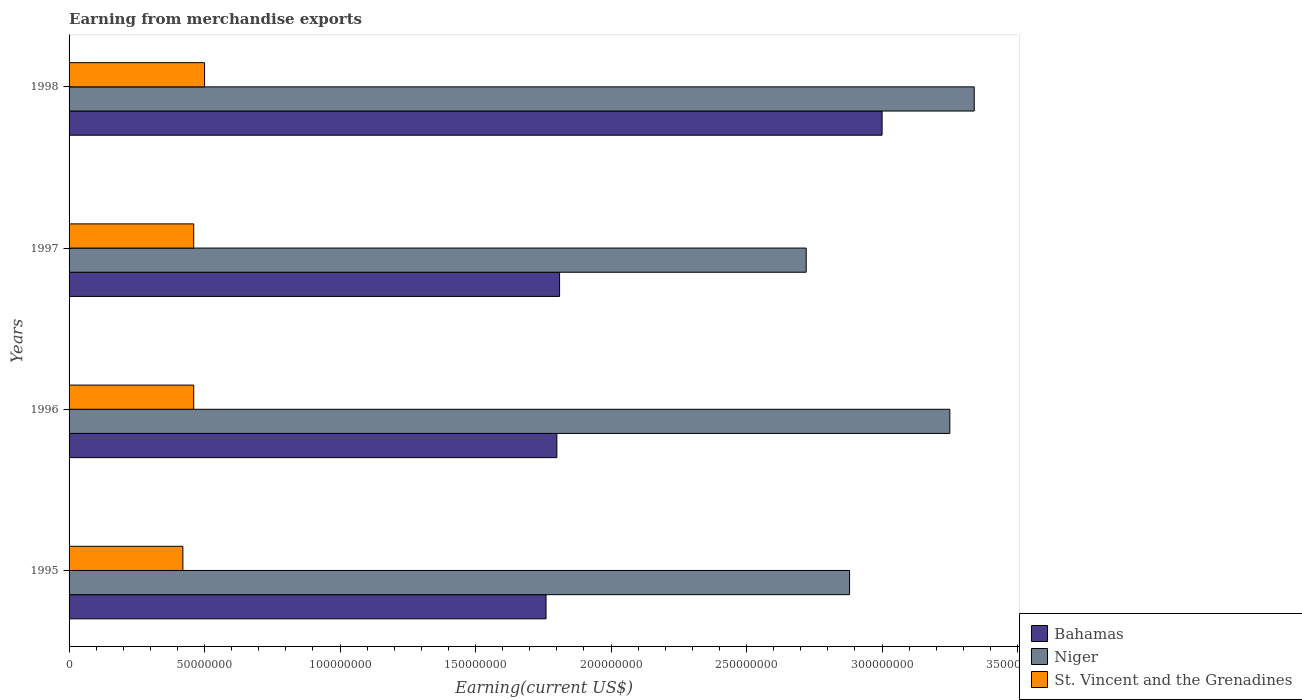How many different coloured bars are there?
Keep it short and to the point. 3. How many groups of bars are there?
Provide a succinct answer. 4. Are the number of bars per tick equal to the number of legend labels?
Your answer should be compact. Yes. Are the number of bars on each tick of the Y-axis equal?
Your answer should be compact. Yes. How many bars are there on the 2nd tick from the top?
Provide a succinct answer. 3. What is the label of the 1st group of bars from the top?
Offer a terse response. 1998. What is the amount earned from merchandise exports in Niger in 1996?
Your answer should be compact. 3.25e+08. Across all years, what is the minimum amount earned from merchandise exports in St. Vincent and the Grenadines?
Make the answer very short. 4.20e+07. In which year was the amount earned from merchandise exports in Niger maximum?
Provide a short and direct response. 1998. What is the total amount earned from merchandise exports in Niger in the graph?
Offer a terse response. 1.22e+09. What is the difference between the amount earned from merchandise exports in St. Vincent and the Grenadines in 1997 and the amount earned from merchandise exports in Niger in 1998?
Provide a short and direct response. -2.88e+08. What is the average amount earned from merchandise exports in Niger per year?
Make the answer very short. 3.05e+08. In the year 1995, what is the difference between the amount earned from merchandise exports in Niger and amount earned from merchandise exports in St. Vincent and the Grenadines?
Offer a terse response. 2.46e+08. In how many years, is the amount earned from merchandise exports in Bahamas greater than 340000000 US$?
Your answer should be very brief. 0. What is the ratio of the amount earned from merchandise exports in Bahamas in 1995 to that in 1996?
Your response must be concise. 0.98. Is the amount earned from merchandise exports in Bahamas in 1995 less than that in 1998?
Your answer should be very brief. Yes. What is the difference between the highest and the second highest amount earned from merchandise exports in Niger?
Give a very brief answer. 9.00e+06. What is the difference between the highest and the lowest amount earned from merchandise exports in Bahamas?
Keep it short and to the point. 1.24e+08. What does the 2nd bar from the top in 1998 represents?
Provide a succinct answer. Niger. What does the 2nd bar from the bottom in 1997 represents?
Offer a terse response. Niger. How many years are there in the graph?
Your answer should be compact. 4. Does the graph contain any zero values?
Your answer should be compact. No. Where does the legend appear in the graph?
Ensure brevity in your answer.  Bottom right. What is the title of the graph?
Offer a very short reply. Earning from merchandise exports. Does "Brazil" appear as one of the legend labels in the graph?
Your answer should be very brief. No. What is the label or title of the X-axis?
Your response must be concise. Earning(current US$). What is the label or title of the Y-axis?
Offer a very short reply. Years. What is the Earning(current US$) of Bahamas in 1995?
Provide a short and direct response. 1.76e+08. What is the Earning(current US$) of Niger in 1995?
Offer a very short reply. 2.88e+08. What is the Earning(current US$) in St. Vincent and the Grenadines in 1995?
Your response must be concise. 4.20e+07. What is the Earning(current US$) in Bahamas in 1996?
Make the answer very short. 1.80e+08. What is the Earning(current US$) in Niger in 1996?
Keep it short and to the point. 3.25e+08. What is the Earning(current US$) in St. Vincent and the Grenadines in 1996?
Make the answer very short. 4.60e+07. What is the Earning(current US$) of Bahamas in 1997?
Make the answer very short. 1.81e+08. What is the Earning(current US$) in Niger in 1997?
Your answer should be very brief. 2.72e+08. What is the Earning(current US$) in St. Vincent and the Grenadines in 1997?
Make the answer very short. 4.60e+07. What is the Earning(current US$) in Bahamas in 1998?
Offer a very short reply. 3.00e+08. What is the Earning(current US$) in Niger in 1998?
Give a very brief answer. 3.34e+08. What is the Earning(current US$) in St. Vincent and the Grenadines in 1998?
Provide a short and direct response. 5.00e+07. Across all years, what is the maximum Earning(current US$) in Bahamas?
Your answer should be very brief. 3.00e+08. Across all years, what is the maximum Earning(current US$) in Niger?
Provide a succinct answer. 3.34e+08. Across all years, what is the minimum Earning(current US$) in Bahamas?
Offer a very short reply. 1.76e+08. Across all years, what is the minimum Earning(current US$) in Niger?
Provide a succinct answer. 2.72e+08. Across all years, what is the minimum Earning(current US$) of St. Vincent and the Grenadines?
Your answer should be very brief. 4.20e+07. What is the total Earning(current US$) of Bahamas in the graph?
Make the answer very short. 8.37e+08. What is the total Earning(current US$) of Niger in the graph?
Give a very brief answer. 1.22e+09. What is the total Earning(current US$) of St. Vincent and the Grenadines in the graph?
Ensure brevity in your answer.  1.84e+08. What is the difference between the Earning(current US$) of Bahamas in 1995 and that in 1996?
Give a very brief answer. -4.00e+06. What is the difference between the Earning(current US$) in Niger in 1995 and that in 1996?
Your response must be concise. -3.70e+07. What is the difference between the Earning(current US$) in Bahamas in 1995 and that in 1997?
Make the answer very short. -5.00e+06. What is the difference between the Earning(current US$) of Niger in 1995 and that in 1997?
Make the answer very short. 1.60e+07. What is the difference between the Earning(current US$) in Bahamas in 1995 and that in 1998?
Provide a short and direct response. -1.24e+08. What is the difference between the Earning(current US$) of Niger in 1995 and that in 1998?
Offer a terse response. -4.60e+07. What is the difference between the Earning(current US$) in St. Vincent and the Grenadines in 1995 and that in 1998?
Ensure brevity in your answer.  -8.00e+06. What is the difference between the Earning(current US$) in Niger in 1996 and that in 1997?
Make the answer very short. 5.30e+07. What is the difference between the Earning(current US$) of Bahamas in 1996 and that in 1998?
Your answer should be compact. -1.20e+08. What is the difference between the Earning(current US$) in Niger in 1996 and that in 1998?
Provide a succinct answer. -9.00e+06. What is the difference between the Earning(current US$) of Bahamas in 1997 and that in 1998?
Offer a terse response. -1.19e+08. What is the difference between the Earning(current US$) in Niger in 1997 and that in 1998?
Provide a short and direct response. -6.20e+07. What is the difference between the Earning(current US$) in St. Vincent and the Grenadines in 1997 and that in 1998?
Provide a succinct answer. -4.00e+06. What is the difference between the Earning(current US$) in Bahamas in 1995 and the Earning(current US$) in Niger in 1996?
Ensure brevity in your answer.  -1.49e+08. What is the difference between the Earning(current US$) in Bahamas in 1995 and the Earning(current US$) in St. Vincent and the Grenadines in 1996?
Give a very brief answer. 1.30e+08. What is the difference between the Earning(current US$) of Niger in 1995 and the Earning(current US$) of St. Vincent and the Grenadines in 1996?
Your answer should be very brief. 2.42e+08. What is the difference between the Earning(current US$) of Bahamas in 1995 and the Earning(current US$) of Niger in 1997?
Offer a very short reply. -9.60e+07. What is the difference between the Earning(current US$) of Bahamas in 1995 and the Earning(current US$) of St. Vincent and the Grenadines in 1997?
Ensure brevity in your answer.  1.30e+08. What is the difference between the Earning(current US$) in Niger in 1995 and the Earning(current US$) in St. Vincent and the Grenadines in 1997?
Your answer should be very brief. 2.42e+08. What is the difference between the Earning(current US$) in Bahamas in 1995 and the Earning(current US$) in Niger in 1998?
Provide a succinct answer. -1.58e+08. What is the difference between the Earning(current US$) in Bahamas in 1995 and the Earning(current US$) in St. Vincent and the Grenadines in 1998?
Provide a short and direct response. 1.26e+08. What is the difference between the Earning(current US$) of Niger in 1995 and the Earning(current US$) of St. Vincent and the Grenadines in 1998?
Provide a short and direct response. 2.38e+08. What is the difference between the Earning(current US$) of Bahamas in 1996 and the Earning(current US$) of Niger in 1997?
Your answer should be compact. -9.20e+07. What is the difference between the Earning(current US$) in Bahamas in 1996 and the Earning(current US$) in St. Vincent and the Grenadines in 1997?
Provide a succinct answer. 1.34e+08. What is the difference between the Earning(current US$) of Niger in 1996 and the Earning(current US$) of St. Vincent and the Grenadines in 1997?
Your response must be concise. 2.79e+08. What is the difference between the Earning(current US$) of Bahamas in 1996 and the Earning(current US$) of Niger in 1998?
Give a very brief answer. -1.54e+08. What is the difference between the Earning(current US$) of Bahamas in 1996 and the Earning(current US$) of St. Vincent and the Grenadines in 1998?
Your answer should be very brief. 1.30e+08. What is the difference between the Earning(current US$) in Niger in 1996 and the Earning(current US$) in St. Vincent and the Grenadines in 1998?
Ensure brevity in your answer.  2.75e+08. What is the difference between the Earning(current US$) of Bahamas in 1997 and the Earning(current US$) of Niger in 1998?
Provide a short and direct response. -1.53e+08. What is the difference between the Earning(current US$) in Bahamas in 1997 and the Earning(current US$) in St. Vincent and the Grenadines in 1998?
Offer a very short reply. 1.31e+08. What is the difference between the Earning(current US$) of Niger in 1997 and the Earning(current US$) of St. Vincent and the Grenadines in 1998?
Your response must be concise. 2.22e+08. What is the average Earning(current US$) in Bahamas per year?
Offer a very short reply. 2.09e+08. What is the average Earning(current US$) in Niger per year?
Offer a terse response. 3.05e+08. What is the average Earning(current US$) of St. Vincent and the Grenadines per year?
Ensure brevity in your answer.  4.60e+07. In the year 1995, what is the difference between the Earning(current US$) in Bahamas and Earning(current US$) in Niger?
Your answer should be compact. -1.12e+08. In the year 1995, what is the difference between the Earning(current US$) in Bahamas and Earning(current US$) in St. Vincent and the Grenadines?
Provide a succinct answer. 1.34e+08. In the year 1995, what is the difference between the Earning(current US$) of Niger and Earning(current US$) of St. Vincent and the Grenadines?
Your response must be concise. 2.46e+08. In the year 1996, what is the difference between the Earning(current US$) in Bahamas and Earning(current US$) in Niger?
Offer a terse response. -1.45e+08. In the year 1996, what is the difference between the Earning(current US$) of Bahamas and Earning(current US$) of St. Vincent and the Grenadines?
Provide a short and direct response. 1.34e+08. In the year 1996, what is the difference between the Earning(current US$) in Niger and Earning(current US$) in St. Vincent and the Grenadines?
Provide a short and direct response. 2.79e+08. In the year 1997, what is the difference between the Earning(current US$) in Bahamas and Earning(current US$) in Niger?
Your answer should be very brief. -9.10e+07. In the year 1997, what is the difference between the Earning(current US$) in Bahamas and Earning(current US$) in St. Vincent and the Grenadines?
Provide a short and direct response. 1.35e+08. In the year 1997, what is the difference between the Earning(current US$) of Niger and Earning(current US$) of St. Vincent and the Grenadines?
Give a very brief answer. 2.26e+08. In the year 1998, what is the difference between the Earning(current US$) of Bahamas and Earning(current US$) of Niger?
Your answer should be compact. -3.40e+07. In the year 1998, what is the difference between the Earning(current US$) of Bahamas and Earning(current US$) of St. Vincent and the Grenadines?
Your response must be concise. 2.50e+08. In the year 1998, what is the difference between the Earning(current US$) in Niger and Earning(current US$) in St. Vincent and the Grenadines?
Your answer should be very brief. 2.84e+08. What is the ratio of the Earning(current US$) in Bahamas in 1995 to that in 1996?
Give a very brief answer. 0.98. What is the ratio of the Earning(current US$) of Niger in 1995 to that in 1996?
Provide a succinct answer. 0.89. What is the ratio of the Earning(current US$) of St. Vincent and the Grenadines in 1995 to that in 1996?
Your answer should be very brief. 0.91. What is the ratio of the Earning(current US$) of Bahamas in 1995 to that in 1997?
Offer a terse response. 0.97. What is the ratio of the Earning(current US$) of Niger in 1995 to that in 1997?
Keep it short and to the point. 1.06. What is the ratio of the Earning(current US$) of St. Vincent and the Grenadines in 1995 to that in 1997?
Keep it short and to the point. 0.91. What is the ratio of the Earning(current US$) in Bahamas in 1995 to that in 1998?
Make the answer very short. 0.59. What is the ratio of the Earning(current US$) in Niger in 1995 to that in 1998?
Ensure brevity in your answer.  0.86. What is the ratio of the Earning(current US$) in St. Vincent and the Grenadines in 1995 to that in 1998?
Offer a very short reply. 0.84. What is the ratio of the Earning(current US$) in Bahamas in 1996 to that in 1997?
Offer a terse response. 0.99. What is the ratio of the Earning(current US$) of Niger in 1996 to that in 1997?
Provide a succinct answer. 1.19. What is the ratio of the Earning(current US$) of Bahamas in 1996 to that in 1998?
Ensure brevity in your answer.  0.6. What is the ratio of the Earning(current US$) of Niger in 1996 to that in 1998?
Keep it short and to the point. 0.97. What is the ratio of the Earning(current US$) in Bahamas in 1997 to that in 1998?
Give a very brief answer. 0.6. What is the ratio of the Earning(current US$) of Niger in 1997 to that in 1998?
Offer a very short reply. 0.81. What is the ratio of the Earning(current US$) in St. Vincent and the Grenadines in 1997 to that in 1998?
Offer a very short reply. 0.92. What is the difference between the highest and the second highest Earning(current US$) in Bahamas?
Provide a short and direct response. 1.19e+08. What is the difference between the highest and the second highest Earning(current US$) in Niger?
Your response must be concise. 9.00e+06. What is the difference between the highest and the second highest Earning(current US$) of St. Vincent and the Grenadines?
Provide a succinct answer. 4.00e+06. What is the difference between the highest and the lowest Earning(current US$) in Bahamas?
Your answer should be compact. 1.24e+08. What is the difference between the highest and the lowest Earning(current US$) of Niger?
Make the answer very short. 6.20e+07. What is the difference between the highest and the lowest Earning(current US$) in St. Vincent and the Grenadines?
Make the answer very short. 8.00e+06. 